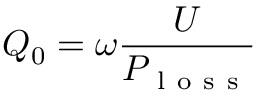Convert formula to latex. <formula><loc_0><loc_0><loc_500><loc_500>Q _ { 0 } = \omega \frac { U } { P _ { l o s s } }</formula> 